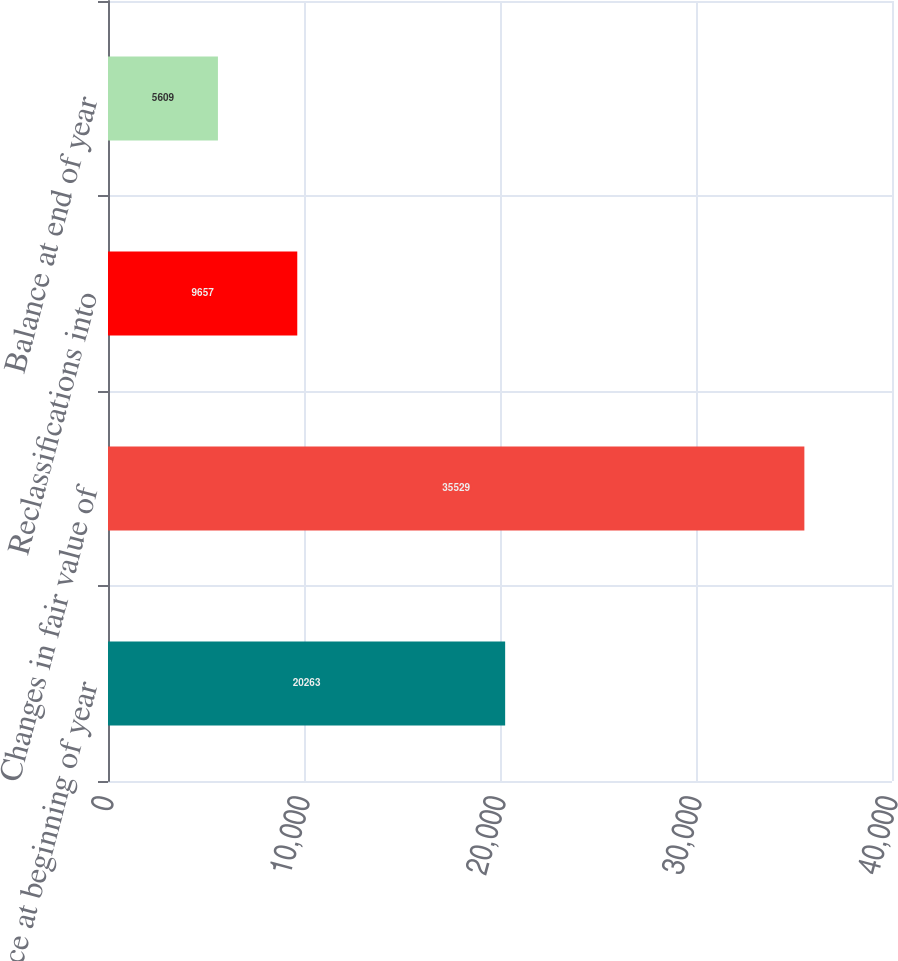Convert chart. <chart><loc_0><loc_0><loc_500><loc_500><bar_chart><fcel>Balance at beginning of year<fcel>Changes in fair value of<fcel>Reclassifications into<fcel>Balance at end of year<nl><fcel>20263<fcel>35529<fcel>9657<fcel>5609<nl></chart> 